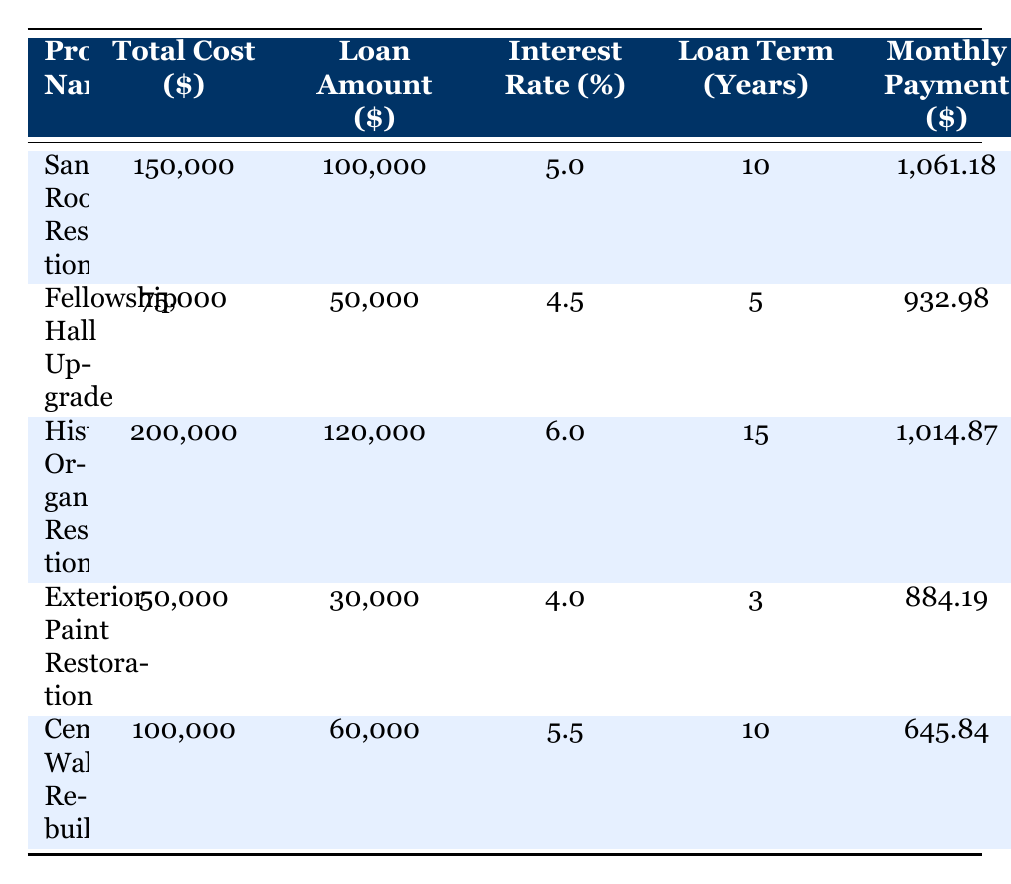What is the total cost of the Sanctuary Roof Restoration project? The table lists the total cost for the Sanctuary Roof Restoration project as $150,000. This value is found in the second column of the row corresponding to this project.
Answer: 150,000 What is the monthly payment for the Fellowship Hall Upgrade project? The Fellowship Hall Upgrade project has a monthly payment listed as $932.98, which is found in the last column of its respective row.
Answer: 932.98 Which project has the highest loan amount? By comparing the loan amounts in the table, the Historic Organ Restoration project has the highest loan amount at $120,000. This can be determined by looking at the loan amount column and identifying the maximum value.
Answer: Historic Organ Restoration Is the interest rate for the Exterior Paint Restoration project lower than 5%? The table shows that the interest rate for the Exterior Paint Restoration project is 4%, which is indeed lower than 5%. Therefore, the statement is true.
Answer: Yes What is the average monthly payment for all projects listed in the table? First, we sum all the monthly payments: 1061.18 + 932.98 + 1014.87 + 884.19 + 645.84 = 4,538.06. Then, we divide this by the number of projects (5) to find the average: 4,538.06 / 5 = 907.61. Thus, the average monthly payment is calculated.
Answer: 907.61 Which project has the longest loan term, and what is its duration? The Historic Organ Restoration project has the longest loan term listed at 15 years. This is determined by reviewing the loan term column and identifying the maximum value.
Answer: Historic Organ Restoration, 15 years How much is the total cost across all projects? To find the total cost, we must add up all the total costs listed: 150,000 + 75,000 + 200,000 + 50,000 + 100,000 = 575,000. This gives us the overall total cost for all projects.
Answer: 575,000 Is the loan term for the Cemetery Wall Rebuild project more than 10 years? The loan term for the Cemetery Wall Rebuild project listed in the table is 10 years, which means it is not more than 10 years. Thus, the statement is false.
Answer: No What is the difference in total cost between the Historic Organ Restoration and the Fellowship Hall Upgrade projects? The total cost of the Historic Organ Restoration project is $200,000, and the Fellowship Hall Upgrade costs $75,000. The difference is calculated as follows: 200,000 - 75,000 = 125,000. This gives us the answer.
Answer: 125,000 